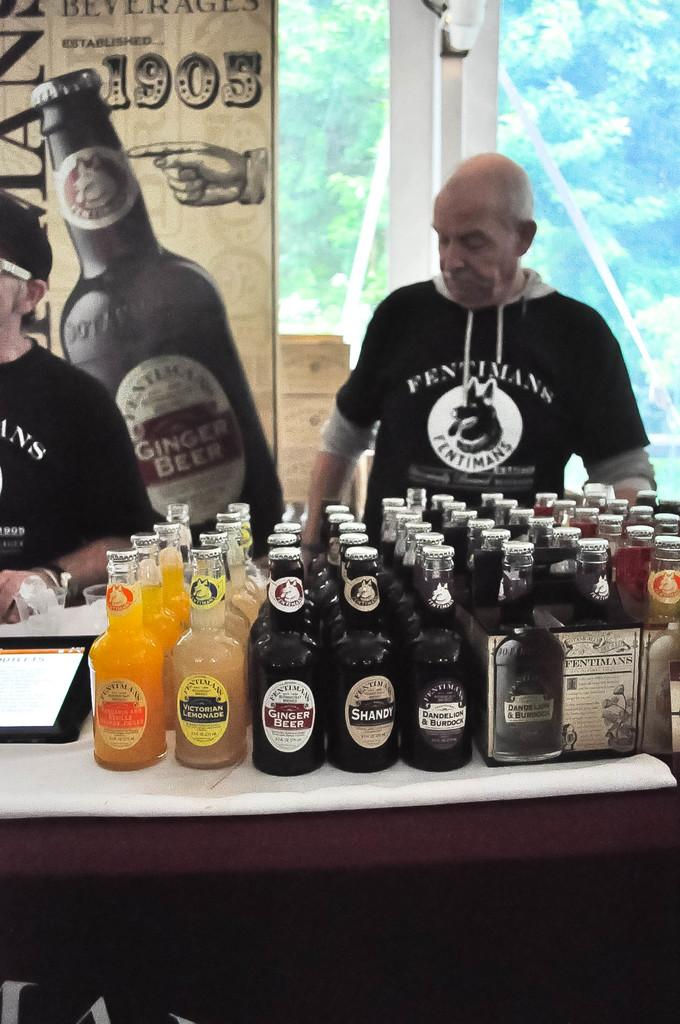<image>
Summarize the visual content of the image. Two men in black shirts are at a store counter that is covered in Ginger Beer bottles. 